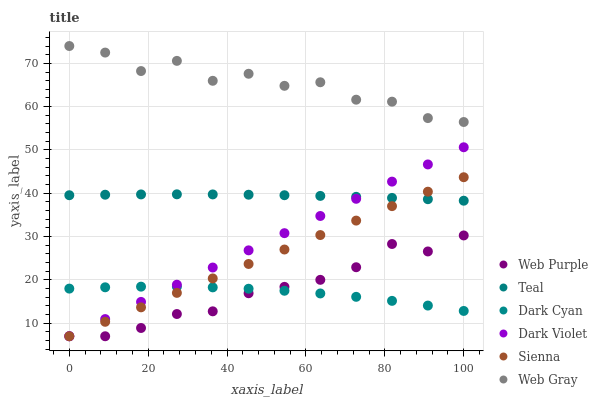Does Dark Cyan have the minimum area under the curve?
Answer yes or no. Yes. Does Web Gray have the maximum area under the curve?
Answer yes or no. Yes. Does Dark Violet have the minimum area under the curve?
Answer yes or no. No. Does Dark Violet have the maximum area under the curve?
Answer yes or no. No. Is Dark Violet the smoothest?
Answer yes or no. Yes. Is Web Gray the roughest?
Answer yes or no. Yes. Is Sienna the smoothest?
Answer yes or no. No. Is Sienna the roughest?
Answer yes or no. No. Does Dark Violet have the lowest value?
Answer yes or no. Yes. Does Teal have the lowest value?
Answer yes or no. No. Does Web Gray have the highest value?
Answer yes or no. Yes. Does Dark Violet have the highest value?
Answer yes or no. No. Is Sienna less than Web Gray?
Answer yes or no. Yes. Is Web Gray greater than Dark Cyan?
Answer yes or no. Yes. Does Dark Violet intersect Teal?
Answer yes or no. Yes. Is Dark Violet less than Teal?
Answer yes or no. No. Is Dark Violet greater than Teal?
Answer yes or no. No. Does Sienna intersect Web Gray?
Answer yes or no. No. 